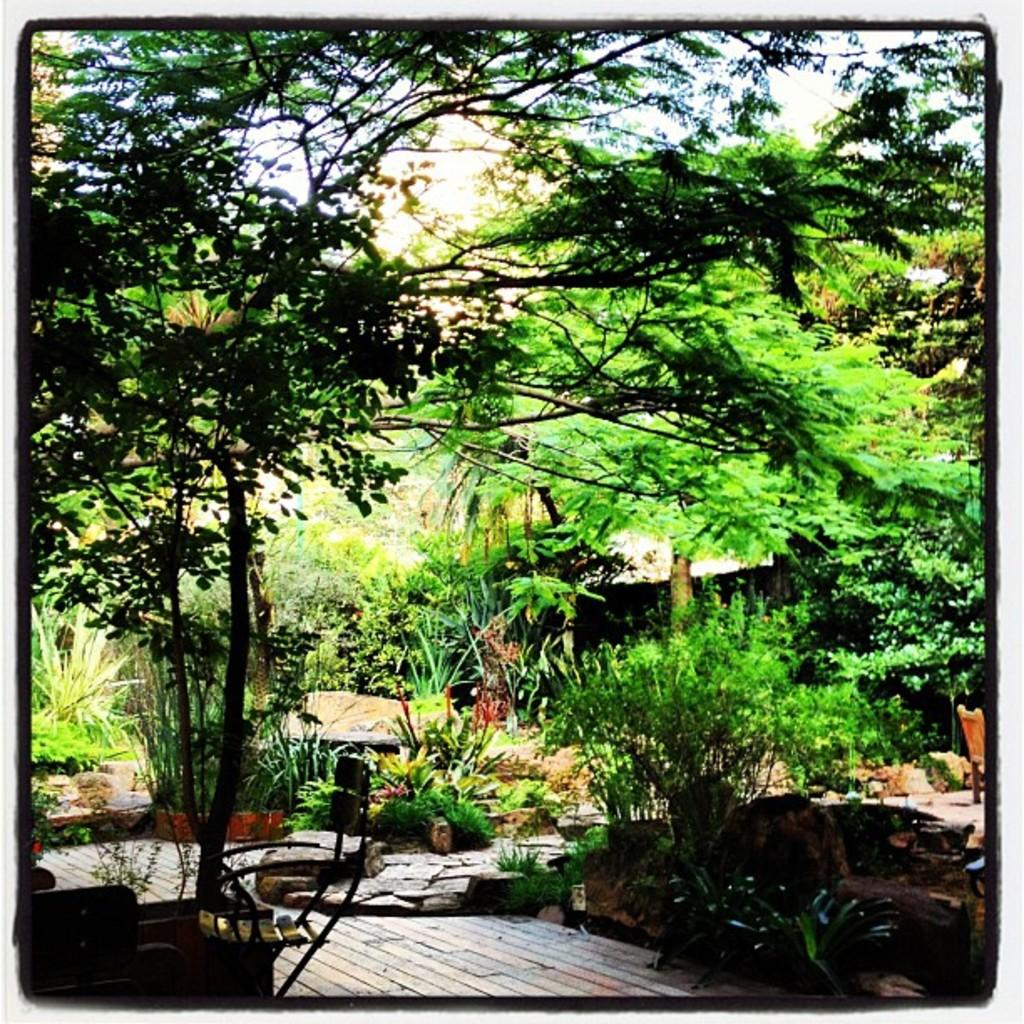What type of furniture is present in the image? There are chairs in the image. What type of vegetation can be seen in the image? There are plants and trees in the image. Where is the cannon located in the image? There is no cannon present in the image. Can you see the toes of the people in the image? There are no people visible in the image, so it is impossible to see their toes. 